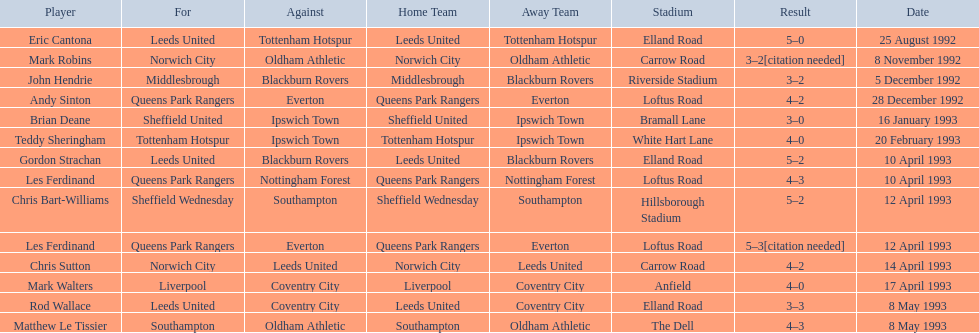Who are the players in 1992-93 fa premier league? Eric Cantona, Mark Robins, John Hendrie, Andy Sinton, Brian Deane, Teddy Sheringham, Gordon Strachan, Les Ferdinand, Chris Bart-Williams, Les Ferdinand, Chris Sutton, Mark Walters, Rod Wallace, Matthew Le Tissier. What is mark robins' result? 3–2[citation needed]. Which player has the same result? John Hendrie. 